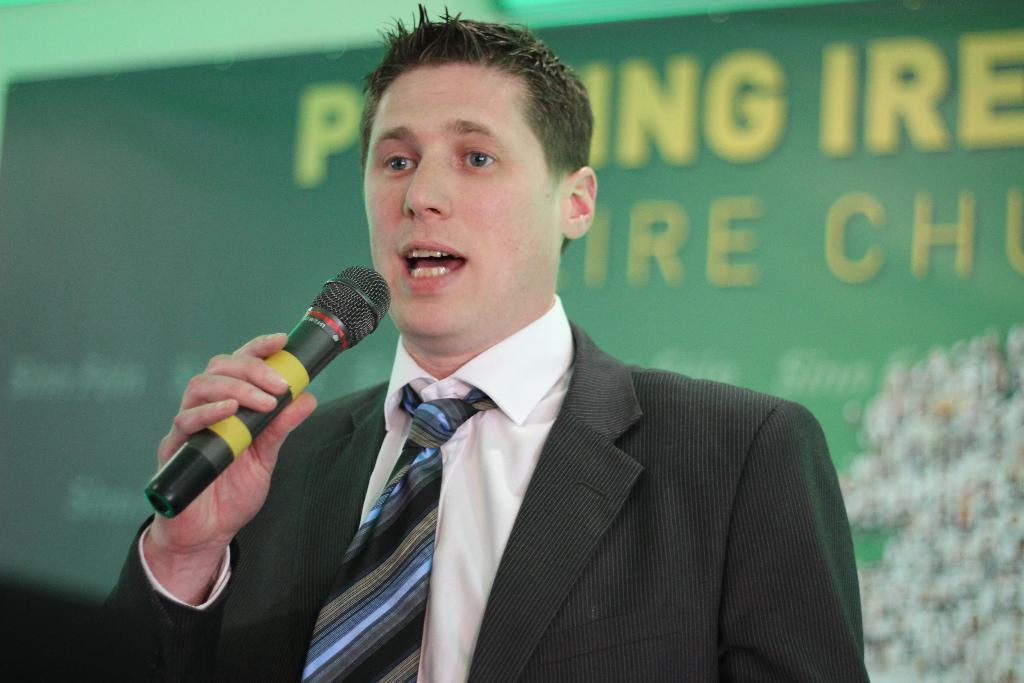Who is present in the image? There is a man in the image. What is the man doing in the image? The man is standing and speaking in the image. What object is associated with the man's speaking activity? There is a microphone in the image. How many chairs are visible in the image? There are no chairs visible in the image. What type of yarn is the man using to speak into the microphone? There is no yarn present in the image, and the man is not using any yarn to speak into the microphone. 